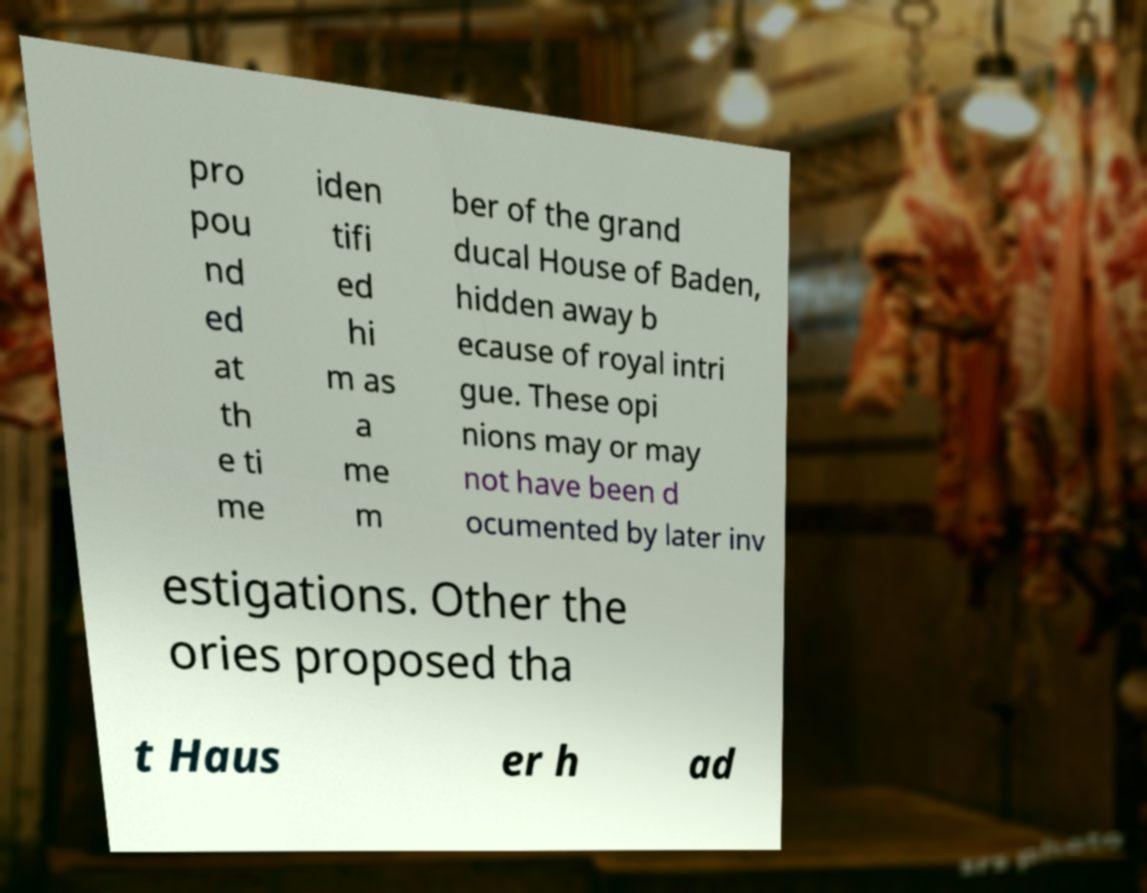I need the written content from this picture converted into text. Can you do that? pro pou nd ed at th e ti me iden tifi ed hi m as a me m ber of the grand ducal House of Baden, hidden away b ecause of royal intri gue. These opi nions may or may not have been d ocumented by later inv estigations. Other the ories proposed tha t Haus er h ad 